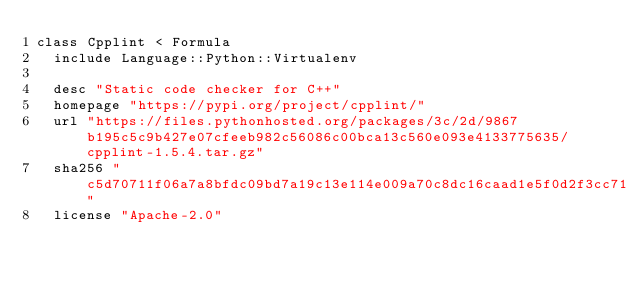<code> <loc_0><loc_0><loc_500><loc_500><_Ruby_>class Cpplint < Formula
  include Language::Python::Virtualenv

  desc "Static code checker for C++"
  homepage "https://pypi.org/project/cpplint/"
  url "https://files.pythonhosted.org/packages/3c/2d/9867b195c5c9b427e07cfeeb982c56086c00bca13c560e093e4133775635/cpplint-1.5.4.tar.gz"
  sha256 "c5d70711f06a7a8bfdc09bd7a19c13e114e009a70c8dc16caad1e5f0d2f3cc71"
  license "Apache-2.0"
</code> 